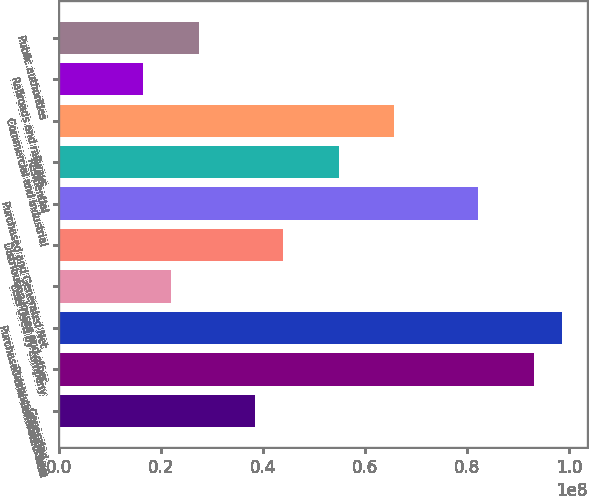Convert chart. <chart><loc_0><loc_0><loc_500><loc_500><bar_chart><fcel>Generated<fcel>Purchased from others<fcel>Purchased and Generated Total<fcel>Less Used by company<fcel>Distribution losses and other<fcel>Purchased and Generated Net<fcel>Residential<fcel>Commercial and industrial<fcel>Railroads and railways<fcel>Public authorities<nl><fcel>3.83425e+07<fcel>9.31175e+07<fcel>9.8595e+07<fcel>2.191e+07<fcel>4.382e+07<fcel>8.21625e+07<fcel>5.4775e+07<fcel>6.573e+07<fcel>1.64325e+07<fcel>2.73875e+07<nl></chart> 